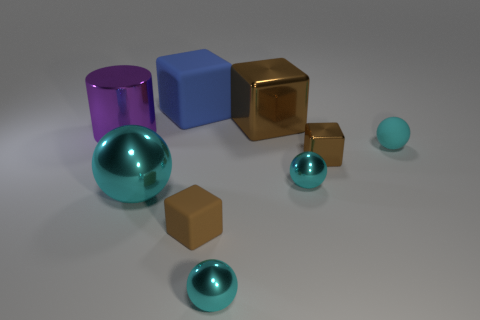Subtract all cyan spheres. How many were subtracted if there are2cyan spheres left? 2 Subtract all big balls. How many balls are left? 3 Subtract all blue blocks. How many blocks are left? 3 Subtract 0 green blocks. How many objects are left? 9 Subtract all cylinders. How many objects are left? 8 Subtract 1 cylinders. How many cylinders are left? 0 Subtract all cyan cylinders. Subtract all blue balls. How many cylinders are left? 1 Subtract all cyan cubes. How many yellow cylinders are left? 0 Subtract all cyan things. Subtract all tiny cyan matte balls. How many objects are left? 4 Add 9 large rubber things. How many large rubber things are left? 10 